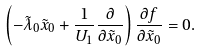Convert formula to latex. <formula><loc_0><loc_0><loc_500><loc_500>\left ( - { \tilde { \lambda } } _ { 0 } { \tilde { x } } _ { 0 } + \frac { 1 } { U _ { 1 } } \frac { \partial } { \partial { \tilde { x } } _ { 0 } } \right ) \frac { \partial f } { \partial { \tilde { x } } _ { 0 } } = 0 .</formula> 